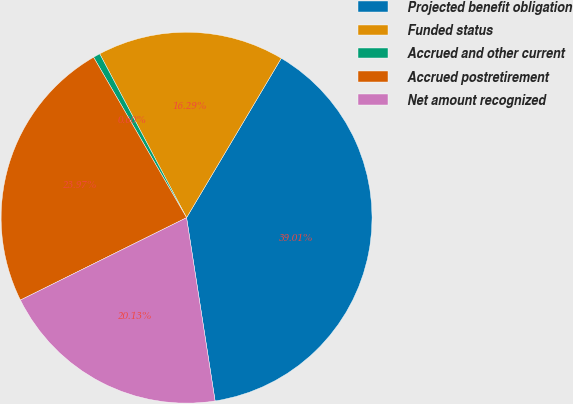<chart> <loc_0><loc_0><loc_500><loc_500><pie_chart><fcel>Projected benefit obligation<fcel>Funded status<fcel>Accrued and other current<fcel>Accrued postretirement<fcel>Net amount recognized<nl><fcel>39.01%<fcel>16.29%<fcel>0.6%<fcel>23.97%<fcel>20.13%<nl></chart> 